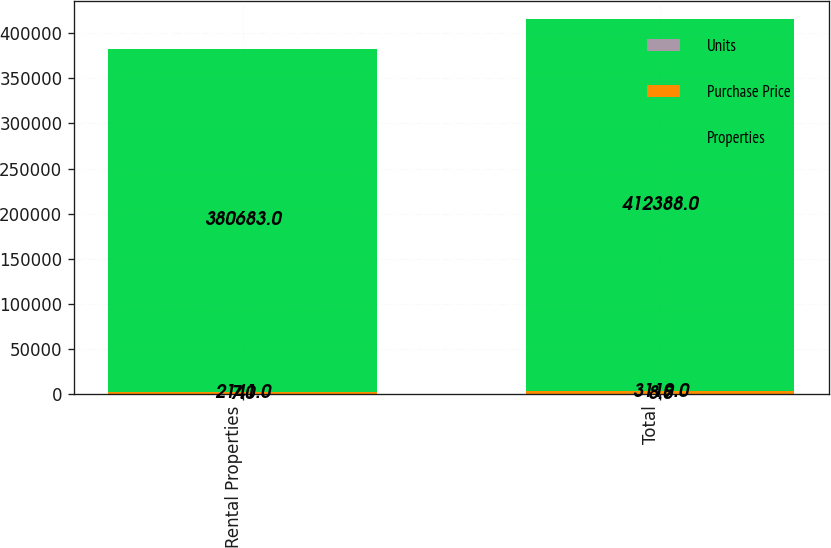Convert chart. <chart><loc_0><loc_0><loc_500><loc_500><stacked_bar_chart><ecel><fcel>Rental Properties<fcel>Total<nl><fcel>Units<fcel>7<fcel>8<nl><fcel>Purchase Price<fcel>2141<fcel>3119<nl><fcel>Properties<fcel>380683<fcel>412388<nl></chart> 